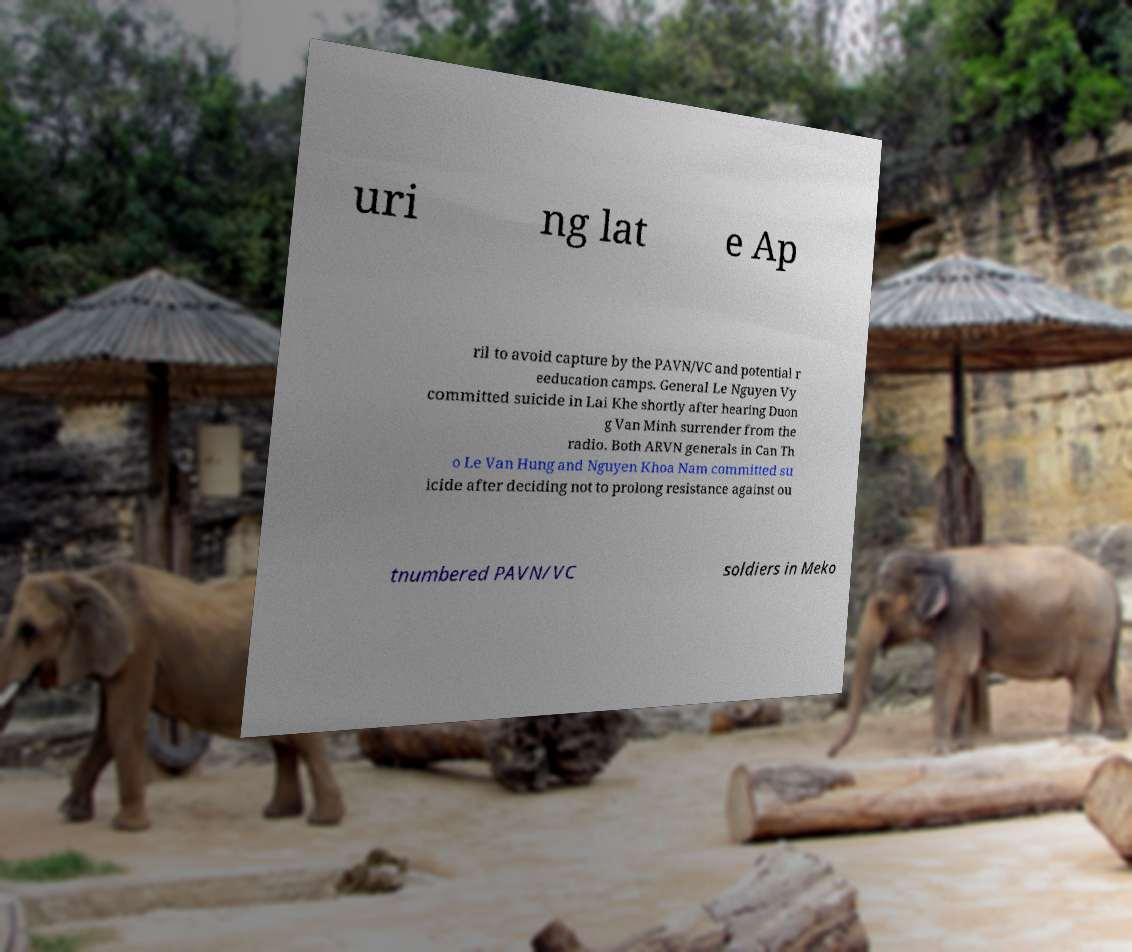Could you assist in decoding the text presented in this image and type it out clearly? uri ng lat e Ap ril to avoid capture by the PAVN/VC and potential r eeducation camps. General Le Nguyen Vy committed suicide in Lai Khe shortly after hearing Duon g Van Minh surrender from the radio. Both ARVN generals in Can Th o Le Van Hung and Nguyen Khoa Nam committed su icide after deciding not to prolong resistance against ou tnumbered PAVN/VC soldiers in Meko 